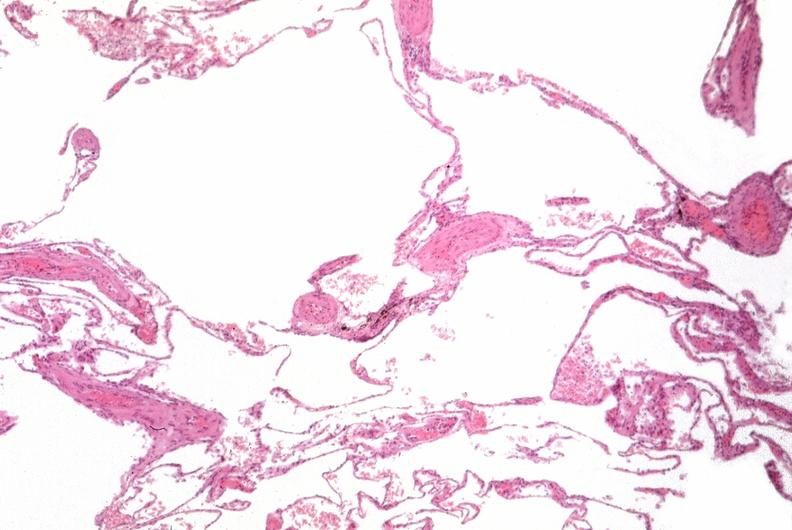where is this?
Answer the question using a single word or phrase. Lung 